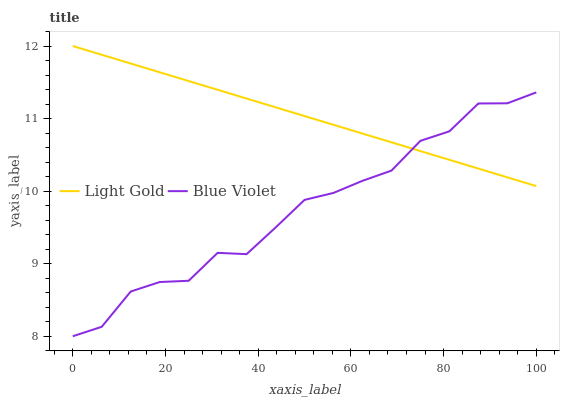Does Blue Violet have the minimum area under the curve?
Answer yes or no. Yes. Does Light Gold have the maximum area under the curve?
Answer yes or no. Yes. Does Blue Violet have the maximum area under the curve?
Answer yes or no. No. Is Light Gold the smoothest?
Answer yes or no. Yes. Is Blue Violet the roughest?
Answer yes or no. Yes. Is Blue Violet the smoothest?
Answer yes or no. No. Does Blue Violet have the lowest value?
Answer yes or no. Yes. Does Light Gold have the highest value?
Answer yes or no. Yes. Does Blue Violet have the highest value?
Answer yes or no. No. Does Light Gold intersect Blue Violet?
Answer yes or no. Yes. Is Light Gold less than Blue Violet?
Answer yes or no. No. Is Light Gold greater than Blue Violet?
Answer yes or no. No. 